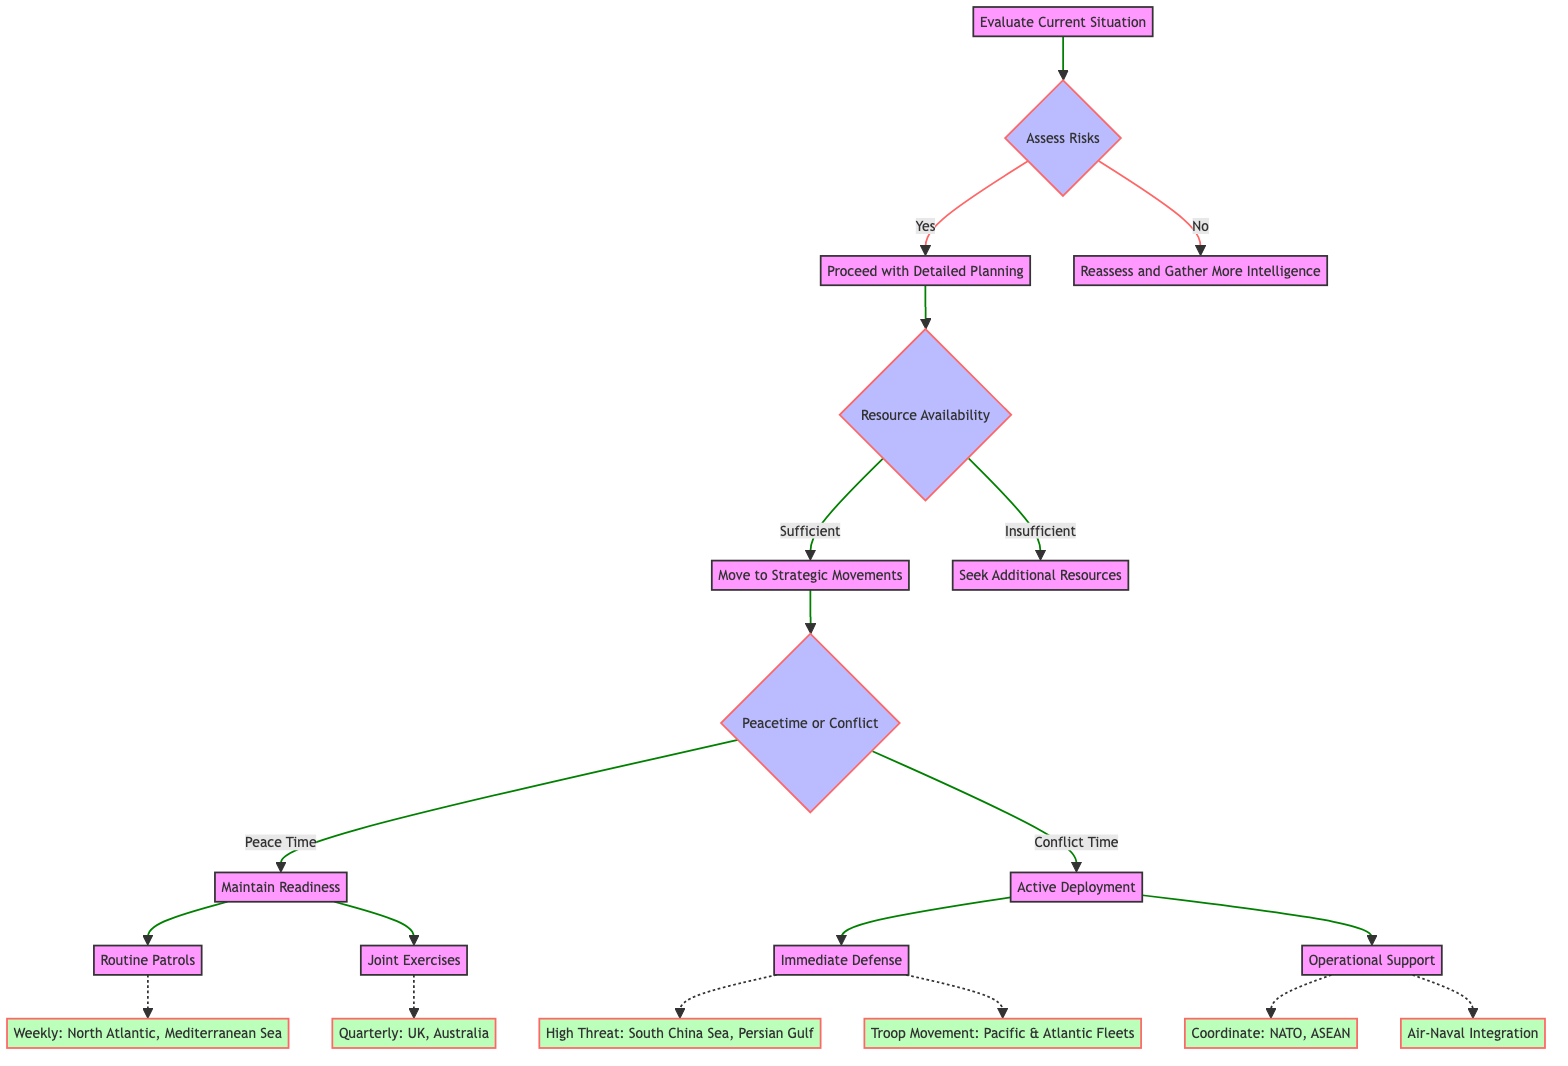What is the first step in the decision tree? The decision tree starts with evaluating the current situation, which is the first action taken before any assessment of risks begins.
Answer: Evaluate Current Situation What happens if the assessment of risks is "Yes"? If the assessment of risks is "Yes", the decision tree directs to "Proceed with Detailed Planning" as the next action, indicating the pathway when risks are assessed positively.
Answer: Proceed with Detailed Planning How many primary actions are there during peace time? In the peace time section, there are two primary actions listed: "Routine Patrols" and "Joint Exercises". This can be counted from the diagram under the peace time objective.
Answer: 2 What type of planning occurs if resources are insufficient? If resources are insufficient, the next step directed by the decision tree is to "Seek Additional Resources". This response addresses situations where resource availability does not meet needs.
Answer: Seek Additional Resources In conflict time, what is the primary objective? The primary objective during conflict time, as specified in the diagram, is "Active Deployment". This is a key strategic goal described under the conflict time section.
Answer: Active Deployment What is the frequency of routine patrols? The frequency for routine patrols in the peace time section is specified as "Weekly", indicating how often patrols are to be conducted.
Answer: Weekly Which allies are coordinated with during operational support? During operational support, coordination occurs with "NATO" and "ASEAN" as specified in the diagram, detailing the alliances for support operations.
Answer: NATO, ASEAN How many high threat areas are listed under immediate defense? There are two high threat areas listed under immediate defense: "South China Sea" and "Persian Gulf". This is determined by counting the entries in the immediate defense section.
Answer: 2 What action follows if resources are sufficient in detailed planning? If resources are sufficient, the next action in the decision tree is to "Move to Strategic Movements", indicating a progression to the movements stage in planning.
Answer: Move to Strategic Movements 